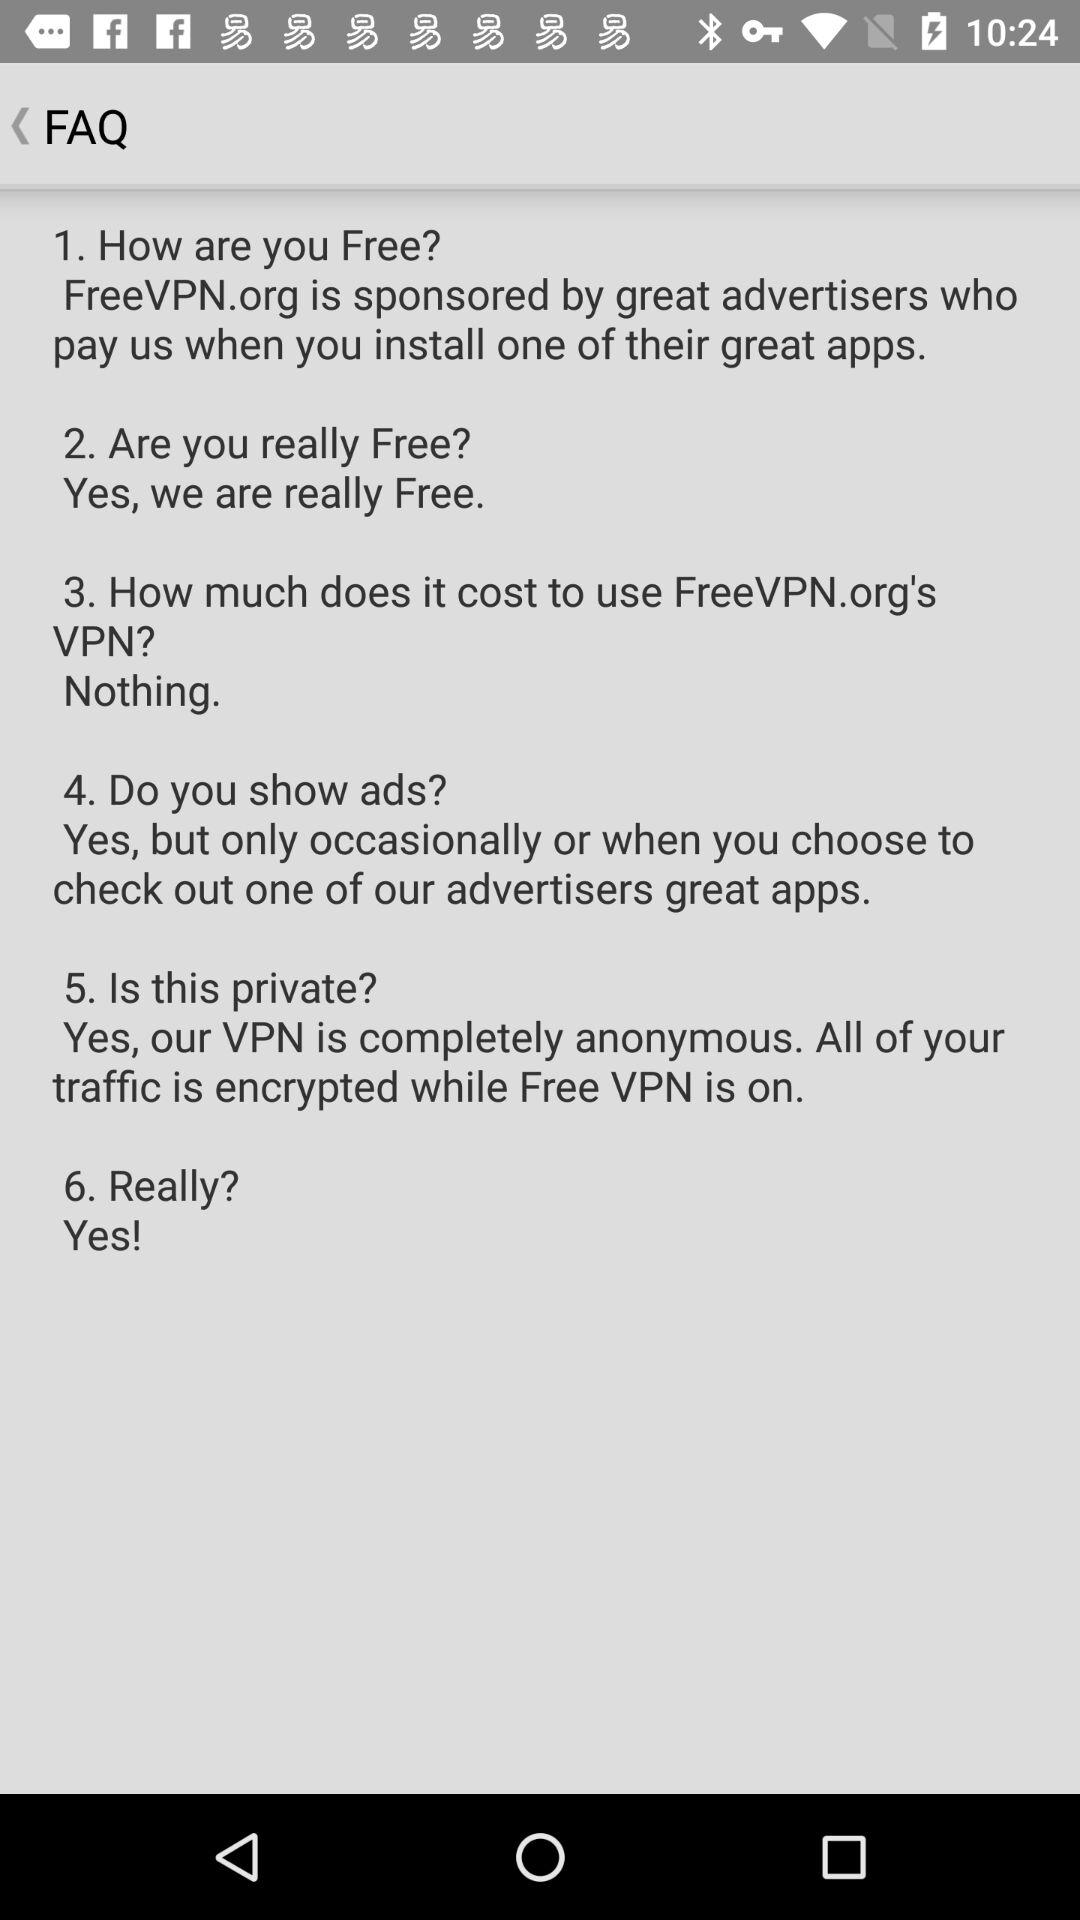Do you show ads? Yes, but only occasionally or when you choose to check out one of our advertisers great apps. 